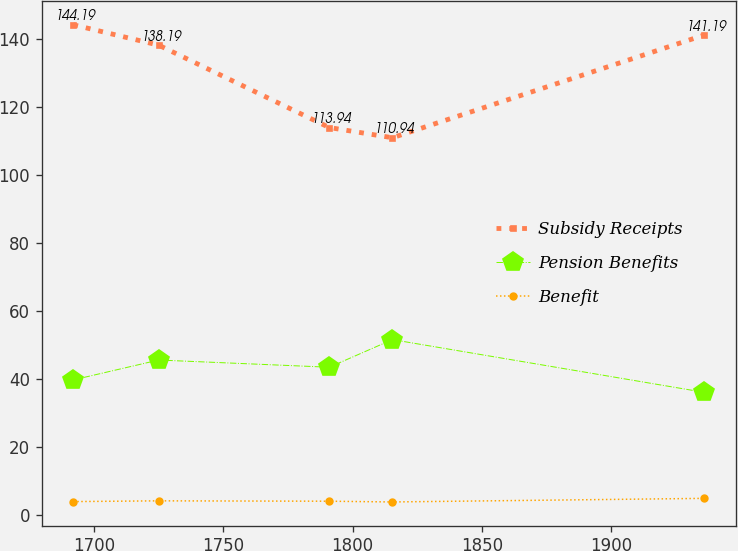Convert chart to OTSL. <chart><loc_0><loc_0><loc_500><loc_500><line_chart><ecel><fcel>Subsidy Receipts<fcel>Pension Benefits<fcel>Benefit<nl><fcel>1691.95<fcel>144.19<fcel>39.66<fcel>3.84<nl><fcel>1724.97<fcel>138.19<fcel>45.51<fcel>4.06<nl><fcel>1790.95<fcel>113.94<fcel>43.39<fcel>3.95<nl><fcel>1815.36<fcel>110.94<fcel>51.52<fcel>3.73<nl><fcel>1936.04<fcel>141.19<fcel>35.99<fcel>4.79<nl></chart> 